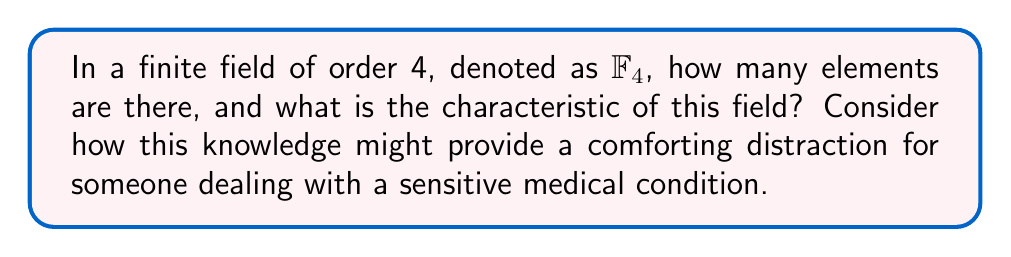Show me your answer to this math problem. Let's approach this step-by-step:

1) A finite field of order 4, $\mathbb{F}_4$, has exactly 4 elements. This is by definition of the order of a field.

2) To determine the characteristic of the field, we need to find the smallest positive integer $n$ such that:

   $\underbrace{1 + 1 + ... + 1}_{n \text{ times}} = 0$

   where 1 is the multiplicative identity of the field.

3) In $\mathbb{F}_4$, we have:
   $1 + 1 \neq 0$ (as $2 \neq 0$ in $\mathbb{F}_4$)
   $1 + 1 + 1 \neq 0$ (as $3 \neq 0$ in $\mathbb{F}_4$)
   $1 + 1 + 1 + 1 = 0$ (as $4 = 0$ in $\mathbb{F}_4$)

4) Therefore, the characteristic of $\mathbb{F}_4$ is 2.

5) The elements of $\mathbb{F}_4$ can be represented as $\{0, 1, \alpha, \alpha + 1\}$, where $\alpha$ is a root of the irreducible polynomial $x^2 + x + 1$ over $\mathbb{F}_2$.

This exploration of a finite field's structure can serve as a gentle mental exercise, offering a brief respite from physical discomfort and demonstrating that even in constrained systems, there's a rich underlying structure to discover.
Answer: 4 elements; characteristic 2 